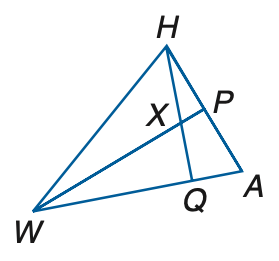Answer the mathemtical geometry problem and directly provide the correct option letter.
Question: If W P is a perpendicular bisector, m \angle W H A = 8 q + 17, m \angle H W P = 10 + q, A P = 6 r + 4, and P H = 22 + 3 r, find r.
Choices: A: 6 B: 7 C: 8 D: 9 A 